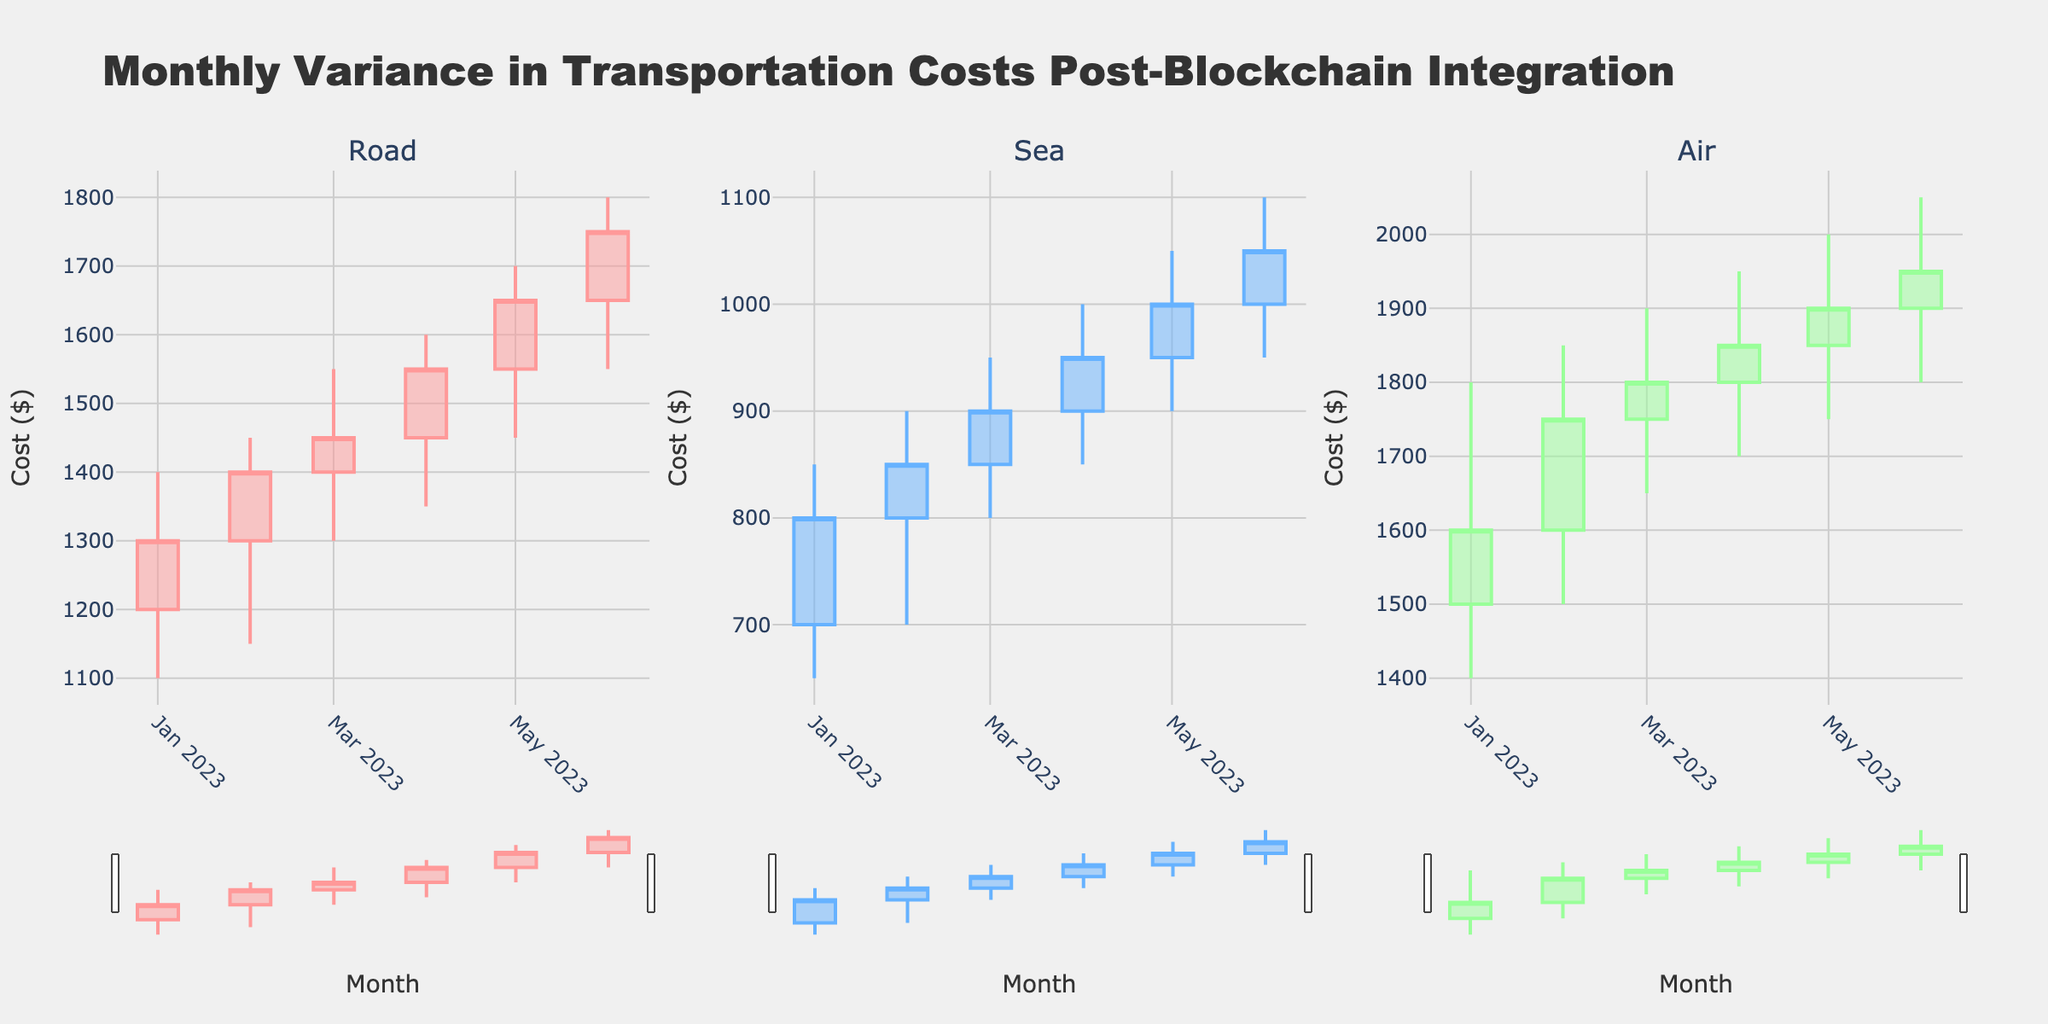what is the title of the figure? The title of a chart is typically located at the top in a prominent position. In this case, the title is clearly visible above the three subplots and reads "Monthly Variance in Transportation Costs Post-Blockchain Integration".
Answer: Monthly Variance in Transportation Costs Post-Blockchain Integration what is the color used for the Road transportation method in the plot? The color used for each transportation method can be noted from the figure's elements. In this plot, the candlestick sections for "Road" transportation are highlighted in a pinkish-red color when the value increases.
Answer: pinkish-red How much did the transportation cost by sea increase from January 2023 to June 2023? The transportation cost by sea can be calculated by comparing the closing prices of the candlestick plots from January and June 2023. The closing price for January 2023 is $800, and for June 2023 it is $1050. The increase is $1050 - $800.
Answer: $250 What was the highest transportation cost by air in any month according to the figure? To identify the highest transportation cost by air, we look for the highest peak in the candlestick plot for "Air". The highest value observed is in June 2023, where the high is noted at $2050.
Answer: $2050 Which transportation method shows the smallest range in cost fluctuation in June 2023? The range in cost fluctuation can be determined by finding the difference between the high and low values in June 2023 for each transportation method: Road (1800-1550 = 250), Sea (1100-950 = 150), and Air (2050-1800 = 250). The smallest range is for Sea transportation.
Answer: Sea From which month did the transportation cost by road begin to consistently increase, according to the plot? To determine the month where the cost by road began to increase consistently, we observe the close values of the candlestick for successive months. The cost closes show rising trends from March 2023 ($1450) onwards through to June 2023 ($1750). The consistent increase begins in March 2023.
Answer: March 2023 Comparing the transportation costs in May 2023, which method had the highest close value? By examining the closing values for May 2023 in all three subplots (Road: $1650, Sea: $1000, Air: $1900), the transportation method with the highest closing cost is Air.
Answer: Air What is the difference in the highest transportation costs between Road and Air in June 2023? To find the difference, we look at the maximum (high) values for Road and Air in June 2023, which are $1800 for Road and $2050 for Air. The difference is $2050 - $1800.
Answer: $250 Which month showed the highest volatility in transportation cost by sea? The highest volatility can be observed by calculating the difference between the high and low costs (high - low) in each month for sea transport. Comparing the differences for each month, the highest volatility occurred in January 2023 (850-650 = 200).
Answer: January 2023 